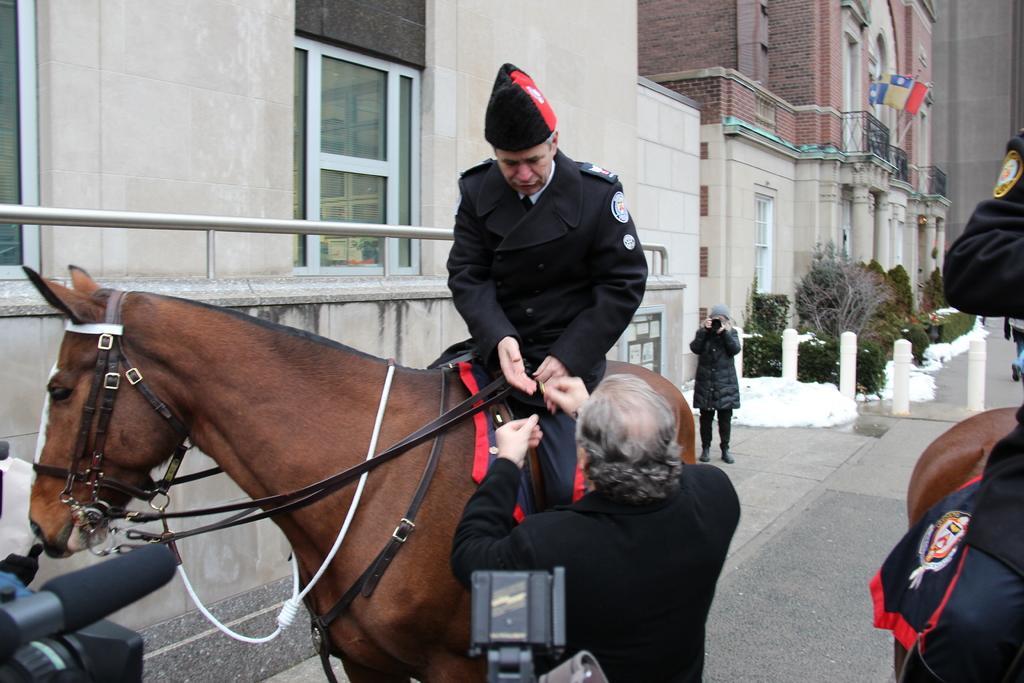Could you give a brief overview of what you see in this image? This picture is inside the city on the road. There is a man sitting on the horse and talking to the person who is standing beside the horse. At the back there is a person holding camera and at the left side there is a building and at the back there are trees and at the top there is a flag. 